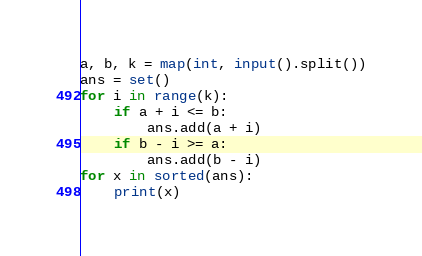<code> <loc_0><loc_0><loc_500><loc_500><_Python_>a, b, k = map(int, input().split())
ans = set()
for i in range(k):
    if a + i <= b:
        ans.add(a + i)
    if b - i >= a:
        ans.add(b - i)
for x in sorted(ans):
    print(x)</code> 